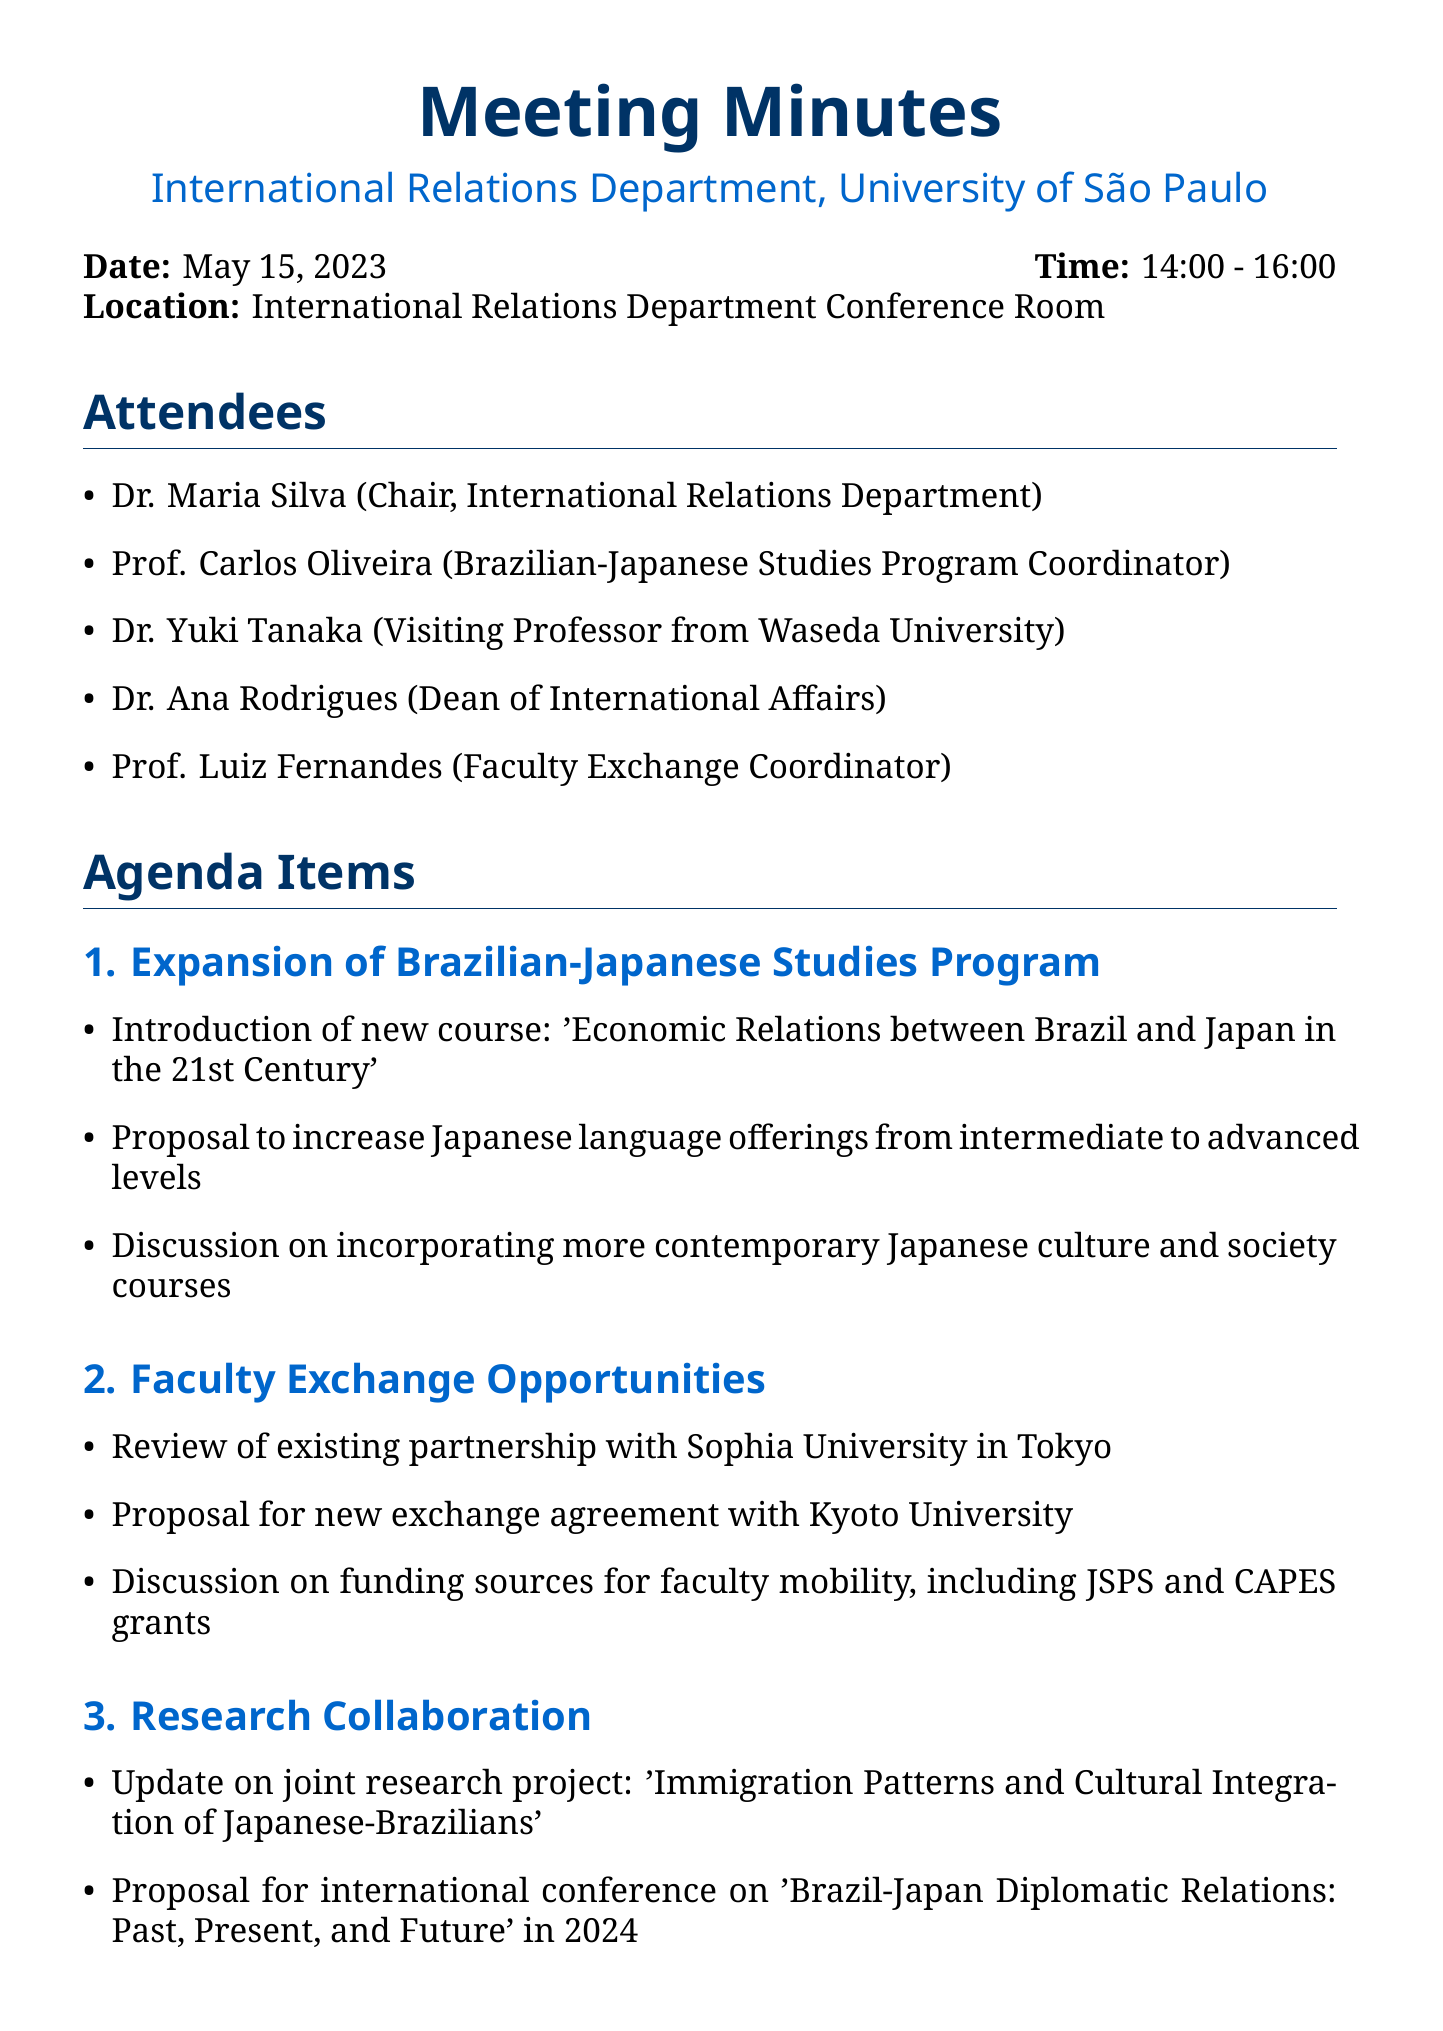What is the date of the meeting? The date of the meeting is specifically mentioned in the document under meeting details.
Answer: May 15, 2023 Who is the Chair of the International Relations Department? The document lists the attendees and their roles, including the Chair of the department.
Answer: Dr. Maria Silva What new course was proposed? The agenda item for the Brazilian-Japanese Studies Program includes the introduction of a specific new course.
Answer: Economic Relations between Brazil and Japan in the 21st Century Which university is proposed for a new exchange agreement? The faculty exchange opportunities section mentions a proposal for a new agreement with a specific university.
Answer: Kyoto University What is the expected deadline for the proposal on the new Economic Relations course? The action items provide deadlines related to the proposals discussed in the meeting.
Answer: June 30, 2023 What is the main focus of the joint research project mentioned? The document provides a title for a joint research project listed under research collaboration.
Answer: Immigration Patterns and Cultural Integration of Japanese-Brazilians Which grants were discussed for faculty mobility funding? The faculty exchange opportunities section discusses specific funding sources for faculty mobility.
Answer: JSPS and CAPES grants What does the organizing committee pertain to? The action items specify the purpose of forming an organizing committee, linked to an upcoming conference.
Answer: 2024 international conference What is the primary concern regarding the student exchange program? The student exchange program agenda item outlines specific goals related to scholarships.
Answer: Increasing scholarship opportunities for Brazilian students to study in Japan 